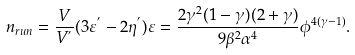Convert formula to latex. <formula><loc_0><loc_0><loc_500><loc_500>n _ { r u n } = \frac { V } { V ^ { ^ { \prime } } } ( 3 \varepsilon ^ { ^ { \prime } } - 2 \eta ^ { ^ { \prime } } ) \varepsilon = \frac { 2 \gamma ^ { 2 } ( 1 - \gamma ) ( 2 + \gamma ) } { 9 \beta ^ { 2 } \alpha ^ { 4 } } \phi ^ { 4 ( \gamma - 1 ) } .</formula> 